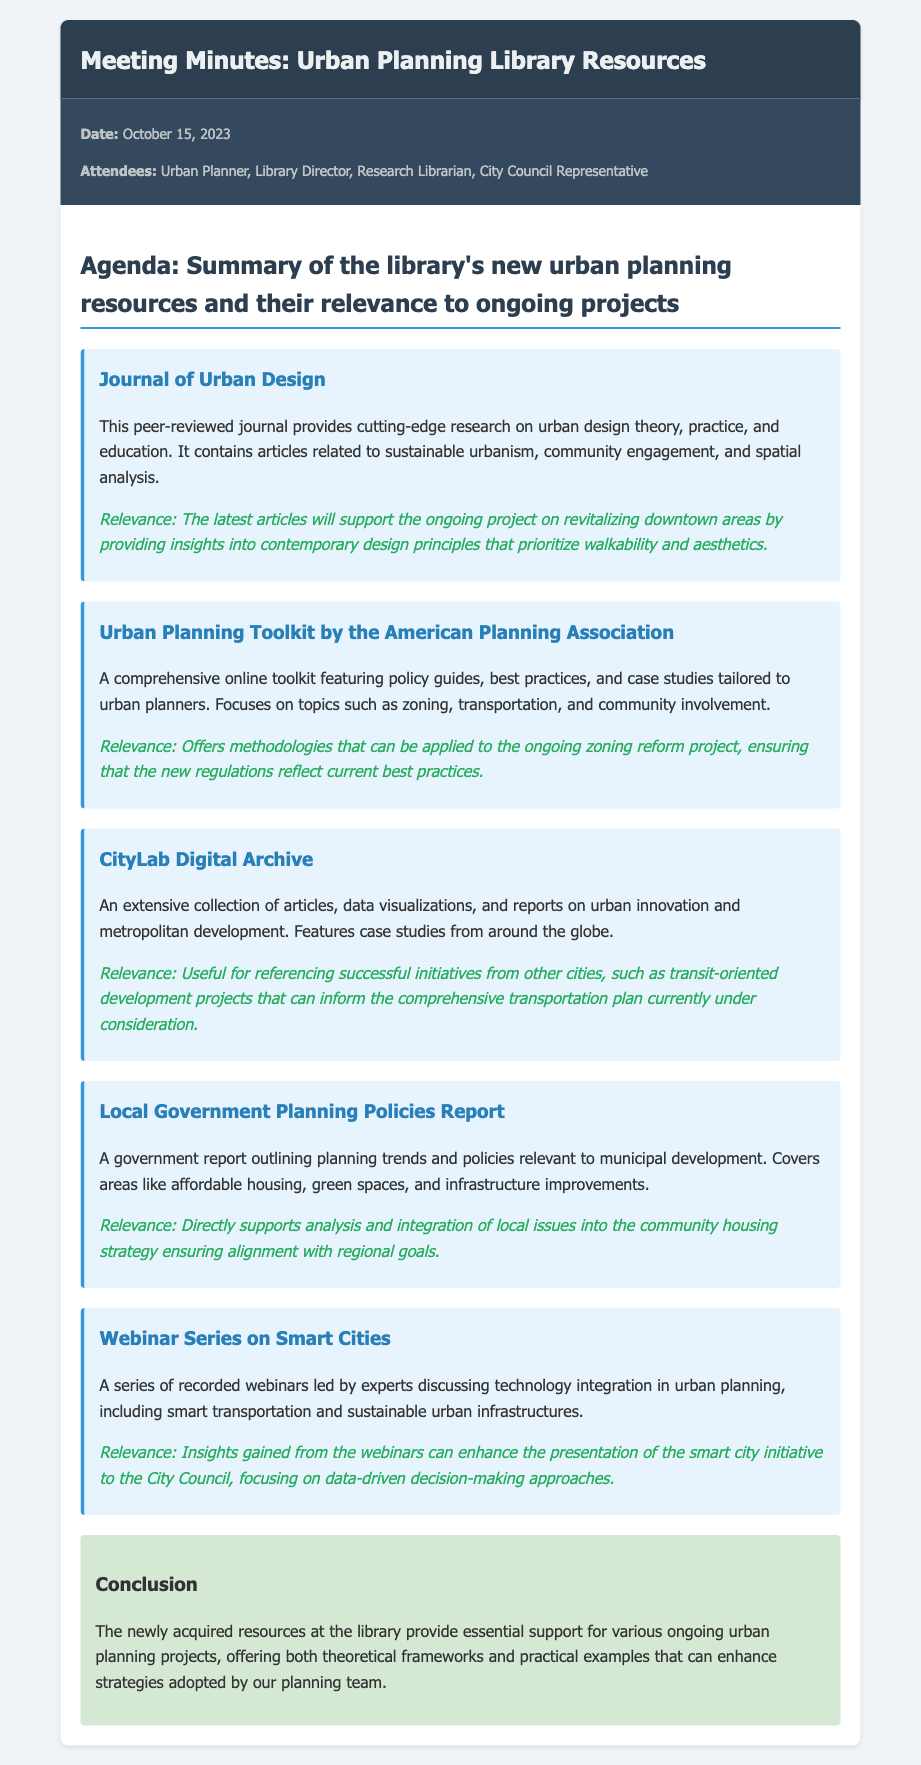what date was the meeting held? The meeting was held on October 15, 2023, as stated in the meeting info section.
Answer: October 15, 2023 who is the author of the Urban Planning Toolkit? The toolkit is by the American Planning Association, as mentioned in the resource title.
Answer: American Planning Association what type of resource is the Journal of Urban Design? The Journal is described as a peer-reviewed journal, which provides cutting-edge research.
Answer: peer-reviewed journal what ongoing project does the CityLab Digital Archive support? It supports the comprehensive transportation plan currently under consideration, as mentioned in the relevance section.
Answer: comprehensive transportation plan how many resources are summarized in the document? The document summarizes five different resources related to urban planning.
Answer: five what is a key focus of the Webinar Series on Smart Cities? The focus includes technology integration in urban planning, as detailed in the description.
Answer: technology integration which resource is directly related to community housing strategy? The resource related to community housing strategy is the Local Government Planning Policies Report.
Answer: Local Government Planning Policies Report what does the conclusion state about the new resources? The conclusion highlights that the new resources provide essential support for urban planning projects.
Answer: essential support for urban planning projects 